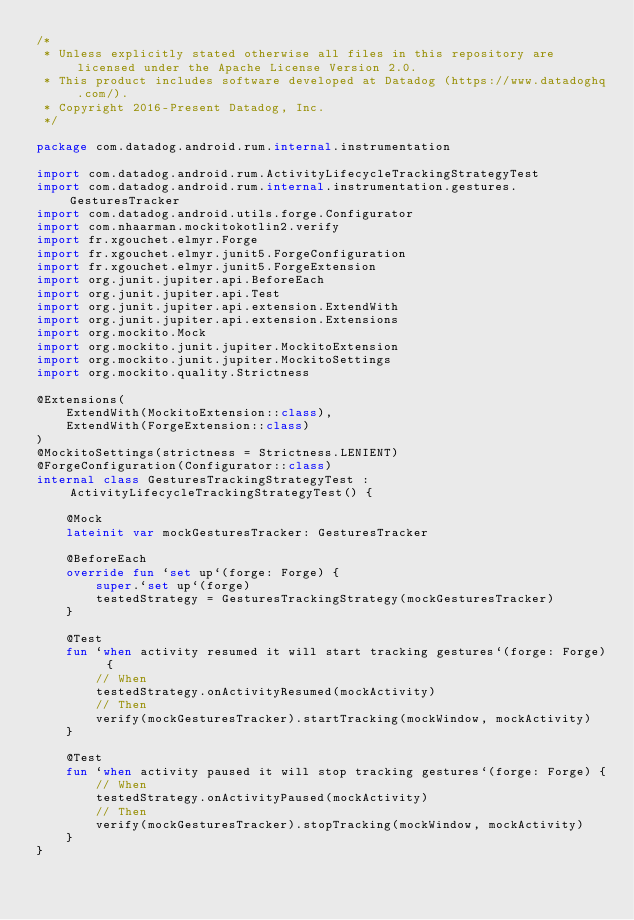Convert code to text. <code><loc_0><loc_0><loc_500><loc_500><_Kotlin_>/*
 * Unless explicitly stated otherwise all files in this repository are licensed under the Apache License Version 2.0.
 * This product includes software developed at Datadog (https://www.datadoghq.com/).
 * Copyright 2016-Present Datadog, Inc.
 */

package com.datadog.android.rum.internal.instrumentation

import com.datadog.android.rum.ActivityLifecycleTrackingStrategyTest
import com.datadog.android.rum.internal.instrumentation.gestures.GesturesTracker
import com.datadog.android.utils.forge.Configurator
import com.nhaarman.mockitokotlin2.verify
import fr.xgouchet.elmyr.Forge
import fr.xgouchet.elmyr.junit5.ForgeConfiguration
import fr.xgouchet.elmyr.junit5.ForgeExtension
import org.junit.jupiter.api.BeforeEach
import org.junit.jupiter.api.Test
import org.junit.jupiter.api.extension.ExtendWith
import org.junit.jupiter.api.extension.Extensions
import org.mockito.Mock
import org.mockito.junit.jupiter.MockitoExtension
import org.mockito.junit.jupiter.MockitoSettings
import org.mockito.quality.Strictness

@Extensions(
    ExtendWith(MockitoExtension::class),
    ExtendWith(ForgeExtension::class)
)
@MockitoSettings(strictness = Strictness.LENIENT)
@ForgeConfiguration(Configurator::class)
internal class GesturesTrackingStrategyTest : ActivityLifecycleTrackingStrategyTest() {

    @Mock
    lateinit var mockGesturesTracker: GesturesTracker

    @BeforeEach
    override fun `set up`(forge: Forge) {
        super.`set up`(forge)
        testedStrategy = GesturesTrackingStrategy(mockGesturesTracker)
    }

    @Test
    fun `when activity resumed it will start tracking gestures`(forge: Forge) {
        // When
        testedStrategy.onActivityResumed(mockActivity)
        // Then
        verify(mockGesturesTracker).startTracking(mockWindow, mockActivity)
    }

    @Test
    fun `when activity paused it will stop tracking gestures`(forge: Forge) {
        // When
        testedStrategy.onActivityPaused(mockActivity)
        // Then
        verify(mockGesturesTracker).stopTracking(mockWindow, mockActivity)
    }
}
</code> 